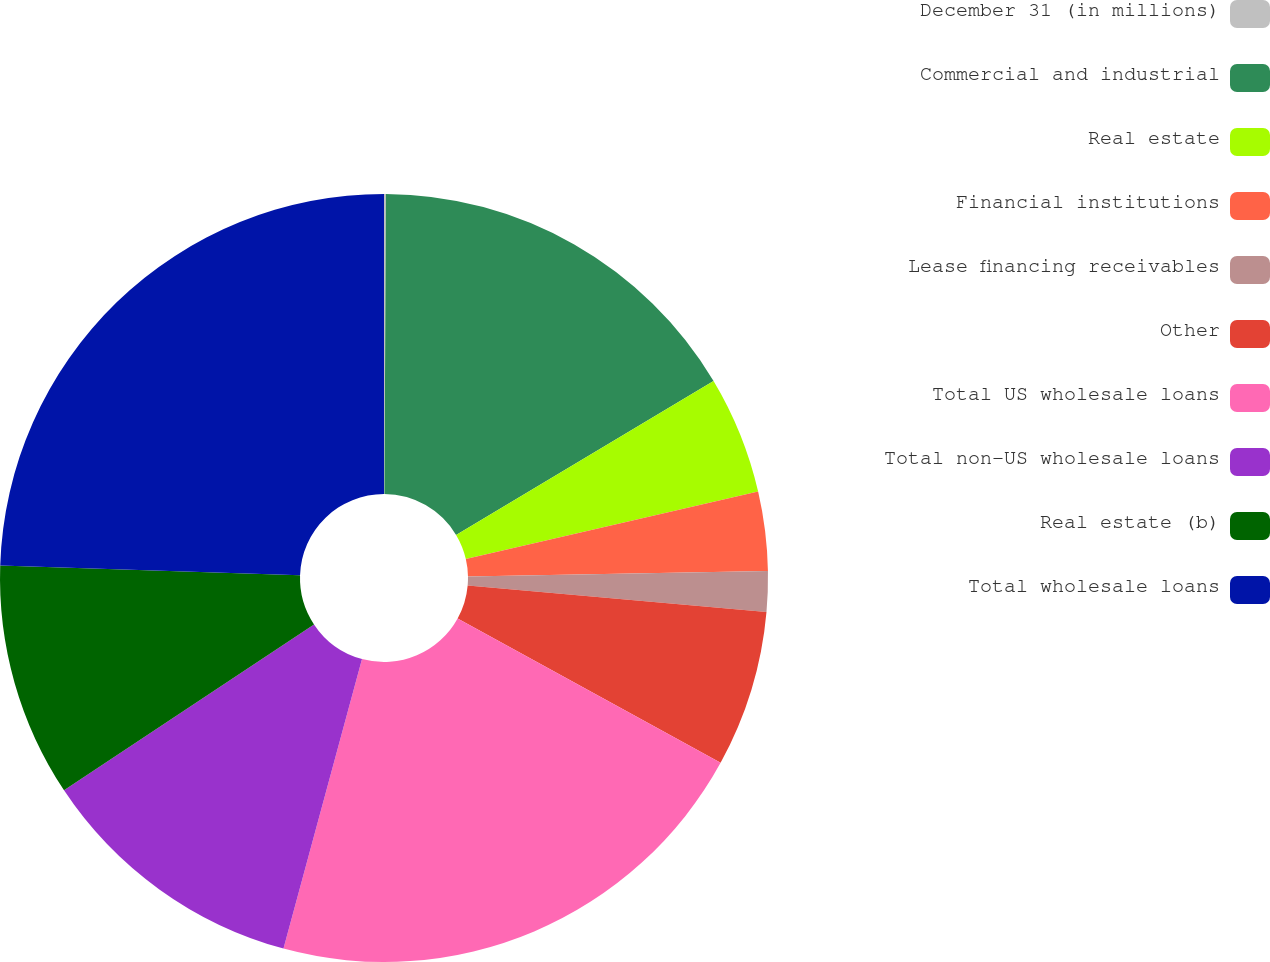Convert chart. <chart><loc_0><loc_0><loc_500><loc_500><pie_chart><fcel>December 31 (in millions)<fcel>Commercial and industrial<fcel>Real estate<fcel>Financial institutions<fcel>Lease financing receivables<fcel>Other<fcel>Total US wholesale loans<fcel>Total non-US wholesale loans<fcel>Real estate (b)<fcel>Total wholesale loans<nl><fcel>0.08%<fcel>16.34%<fcel>4.96%<fcel>3.33%<fcel>1.7%<fcel>6.58%<fcel>21.22%<fcel>11.46%<fcel>9.84%<fcel>24.48%<nl></chart> 